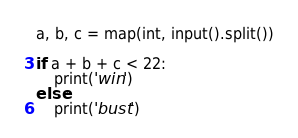Convert code to text. <code><loc_0><loc_0><loc_500><loc_500><_Python_>a, b, c = map(int, input().split())

if a + b + c < 22:
    print('win')
else:
    print('bust')
</code> 